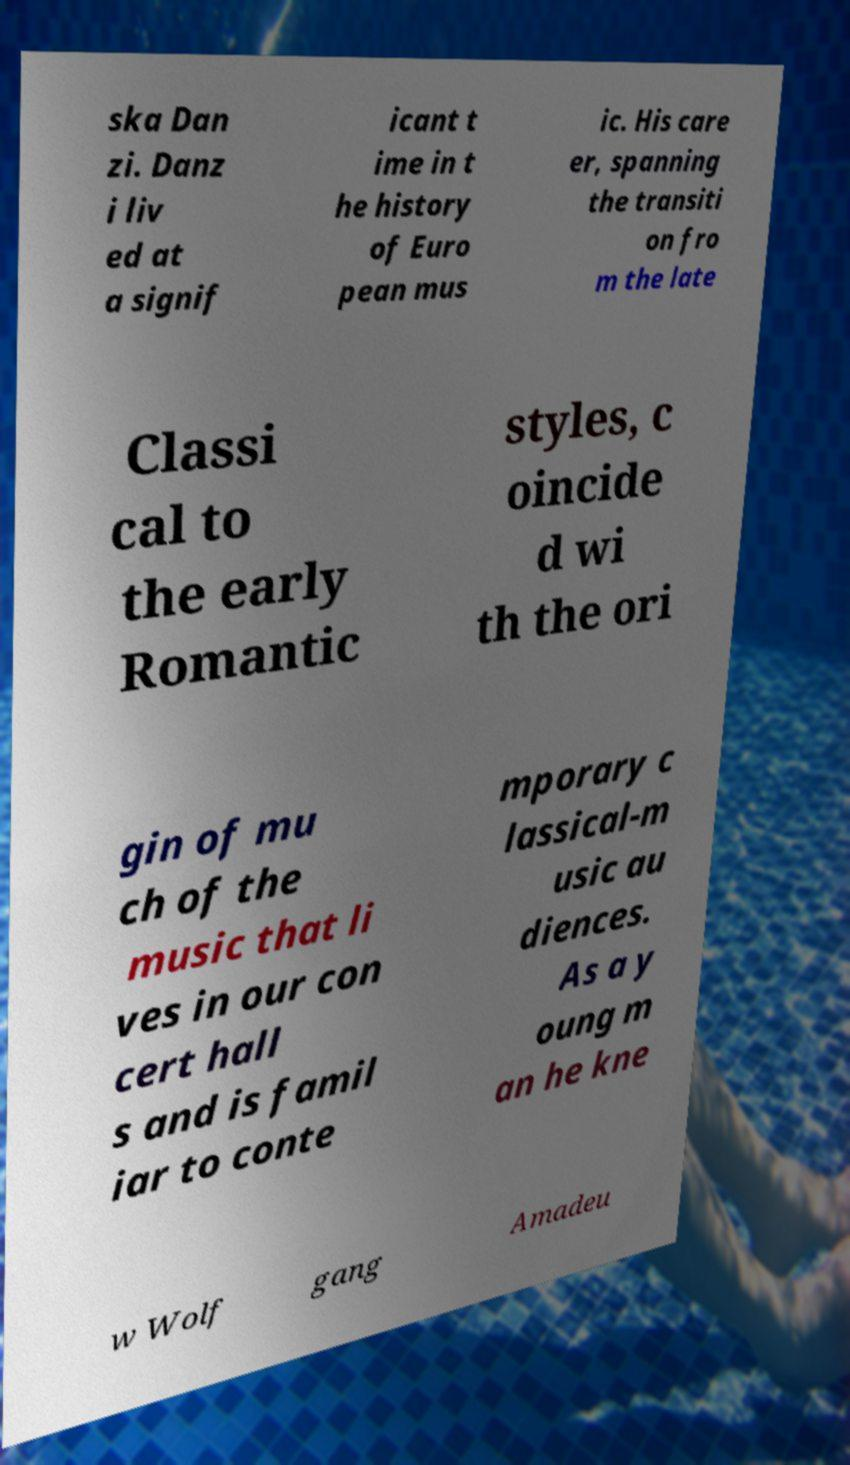Please read and relay the text visible in this image. What does it say? ska Dan zi. Danz i liv ed at a signif icant t ime in t he history of Euro pean mus ic. His care er, spanning the transiti on fro m the late Classi cal to the early Romantic styles, c oincide d wi th the ori gin of mu ch of the music that li ves in our con cert hall s and is famil iar to conte mporary c lassical-m usic au diences. As a y oung m an he kne w Wolf gang Amadeu 